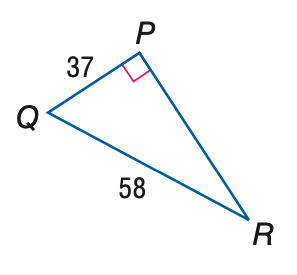Question: Find the measure of \angle R to the nearest tenth.
Choices:
A. 32.5
B. 39.6
C. 50.4
D. 57.5
Answer with the letter. Answer: B 